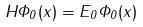<formula> <loc_0><loc_0><loc_500><loc_500>H \Phi _ { 0 } ( x ) = E _ { 0 } \Phi _ { 0 } ( x )</formula> 